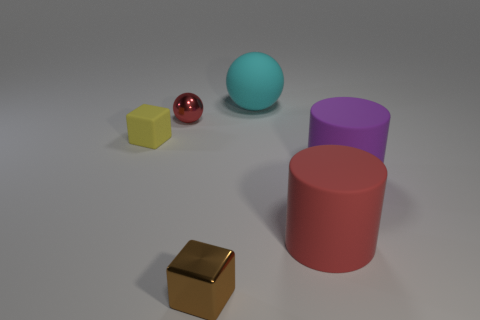What color is the big matte sphere?
Make the answer very short. Cyan. What shape is the red object left of the thing that is behind the red thing left of the big cyan thing?
Your answer should be very brief. Sphere. The block to the left of the ball that is to the left of the large cyan matte sphere is made of what material?
Provide a succinct answer. Rubber. There is a brown object that is the same material as the red ball; what is its shape?
Provide a succinct answer. Cube. There is a brown metallic thing; how many brown metallic blocks are behind it?
Make the answer very short. 0. Are any yellow rubber objects visible?
Offer a terse response. Yes. What color is the large thing behind the shiny object behind the large cylinder on the left side of the big purple matte thing?
Ensure brevity in your answer.  Cyan. There is a rubber object left of the brown metal cube; are there any rubber things in front of it?
Offer a very short reply. Yes. Does the ball that is in front of the rubber ball have the same color as the large rubber cylinder that is in front of the big purple thing?
Make the answer very short. Yes. How many brown cubes have the same size as the purple rubber cylinder?
Your answer should be very brief. 0. 